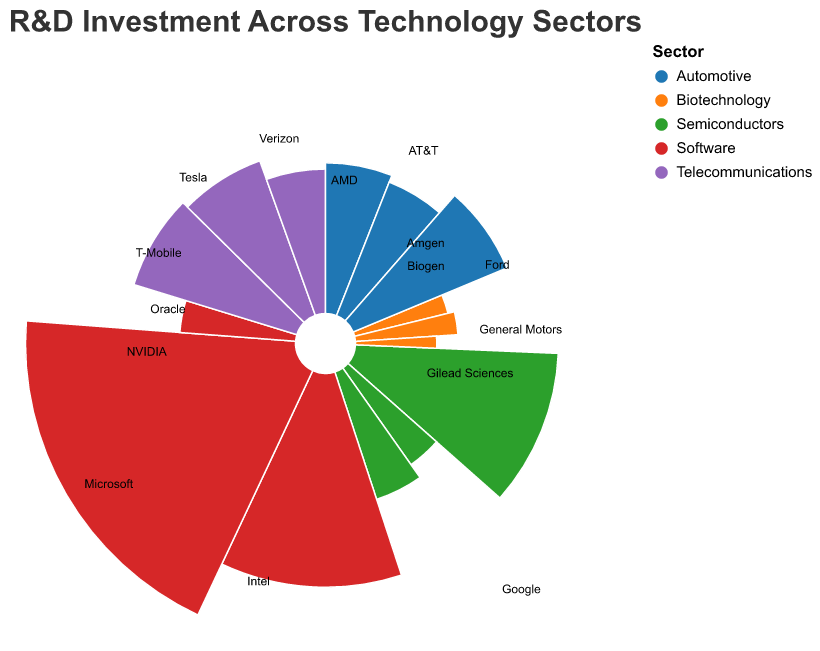What is the title of the chart? The title of the chart is prominently displayed at the top in bold and larger font, which reads "R&D Investment Across Technology Sectors".
Answer: R&D Investment Across Technology Sectors Which sector has the highest R&D investment? By examining the chart, the Software sector has the largest arc segments, indicating it has the highest overall R&D investment.
Answer: Software Which company has the highest R&D investment? Google, within the Software sector, has the highest investment, represented by the largest individual arc segment.
Answer: Google What is the total R&D investment in the Semiconductors sector? The total investment can be calculated by summing the investments of Intel, AMD, and NVIDIA: 15.6 + 5.3 + 6.8 = 27.7 billion USD.
Answer: 27.7 billion USD How does the R&D investment of Tesla compare to that of General Motors? Tesla's investment is 10.5 billion USD, while General Motors' is 8.6 billion USD. Tesla's investment is higher by 1.9 billion USD.
Answer: Tesla's investment is 1.9 billion USD higher What is the average R&D investment per company in the Automotive sector? Add the investments of General Motors, Ford, and Tesla, which equal 8.6 + 7.8 + 10.5 = 26.9 billion USD. Divide by 3, the number of companies: 26.9 / 3 = 8.97 billion USD.
Answer: 8.97 billion USD Which sector has the smallest total R&D investment, and what is the value? By comparing the total investments of each sector, Biotechnology has the smallest total investment with 3.5 + 4.0 + 2.5 = 10.0 billion USD.
Answer: Biotechnology, 10.0 billion USD What is the difference in R&D investment between AT&T and Verizon? AT&T's investment is 11.0 billion USD, while Verizon's is 10.2 billion USD. The difference is calculated as 11.0 - 10.2 = 0.8 billion USD.
Answer: 0.8 billion USD Which company in the Telecommunications sector has the lowest R&D investment? Within the Telecommunications sector, T-Mobile has the smallest arc segment indicating the lowest investment at 7.9 billion USD.
Answer: T-Mobile 